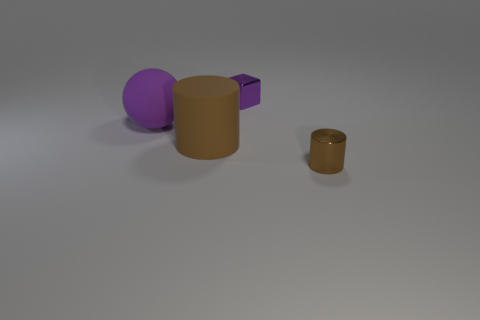Add 3 tiny brown matte things. How many objects exist? 7 Subtract all spheres. How many objects are left? 3 Subtract all big objects. Subtract all matte spheres. How many objects are left? 1 Add 3 big purple balls. How many big purple balls are left? 4 Add 4 tiny metallic objects. How many tiny metallic objects exist? 6 Subtract 0 red spheres. How many objects are left? 4 